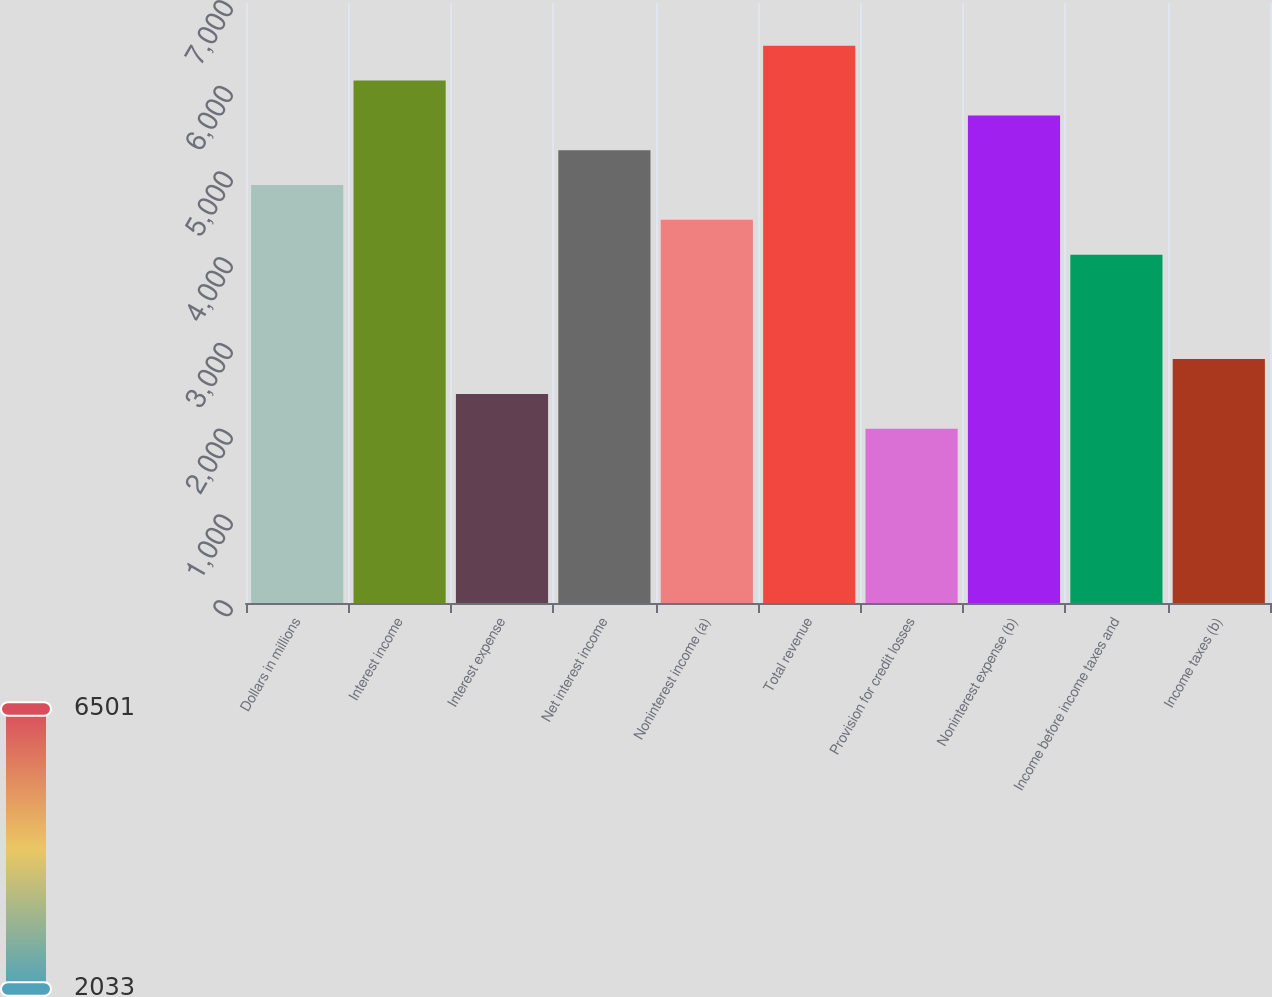Convert chart to OTSL. <chart><loc_0><loc_0><loc_500><loc_500><bar_chart><fcel>Dollars in millions<fcel>Interest income<fcel>Interest expense<fcel>Net interest income<fcel>Noninterest income (a)<fcel>Total revenue<fcel>Provision for credit losses<fcel>Noninterest expense (b)<fcel>Income before income taxes and<fcel>Income taxes (b)<nl><fcel>4876.38<fcel>6094.98<fcel>2439.18<fcel>5282.58<fcel>4470.18<fcel>6501.18<fcel>2032.98<fcel>5688.78<fcel>4063.98<fcel>2845.38<nl></chart> 